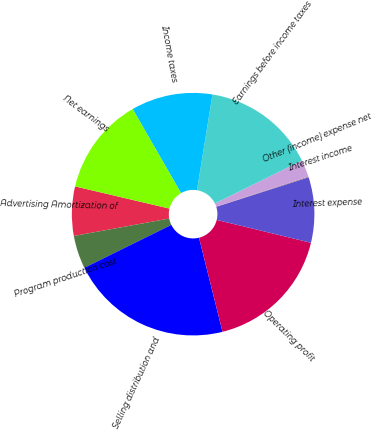Convert chart. <chart><loc_0><loc_0><loc_500><loc_500><pie_chart><fcel>Advertising Amortization of<fcel>Program production cost<fcel>Selling distribution and<fcel>Operating profit<fcel>Interest expense<fcel>Interest income<fcel>Other (income) expense net<fcel>Earnings before income taxes<fcel>Income taxes<fcel>Net earnings<nl><fcel>6.56%<fcel>4.41%<fcel>21.61%<fcel>17.31%<fcel>8.71%<fcel>0.11%<fcel>2.26%<fcel>15.16%<fcel>10.86%<fcel>13.01%<nl></chart> 